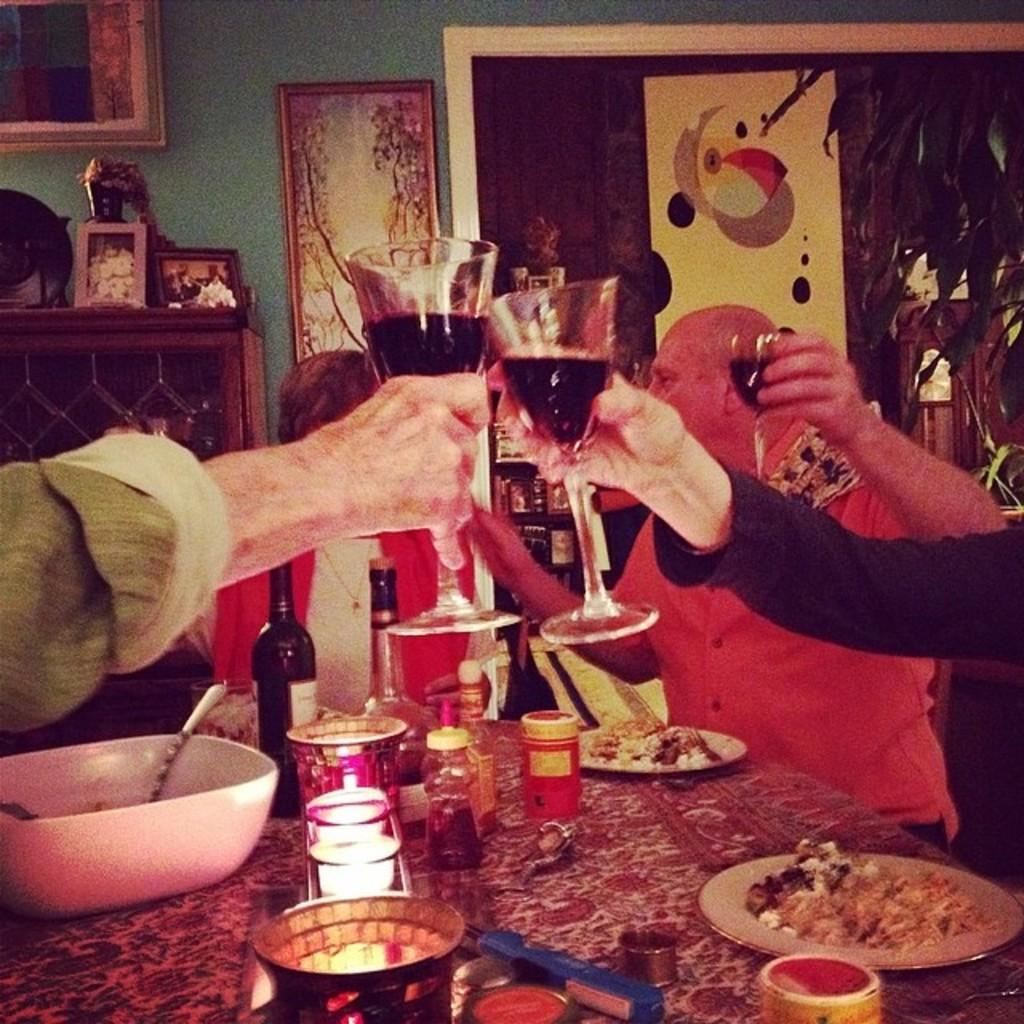What are the people in the image doing? The people in the image are seated on chairs. What are the people holding in their hands? The people are holding wine glasses. What is on the table in the image? There is a bottle and plates with food on the table. What type of silk fabric is draped over the table in the image? There is no silk fabric present in the image; the table only has a bottle and plates with food on it. 